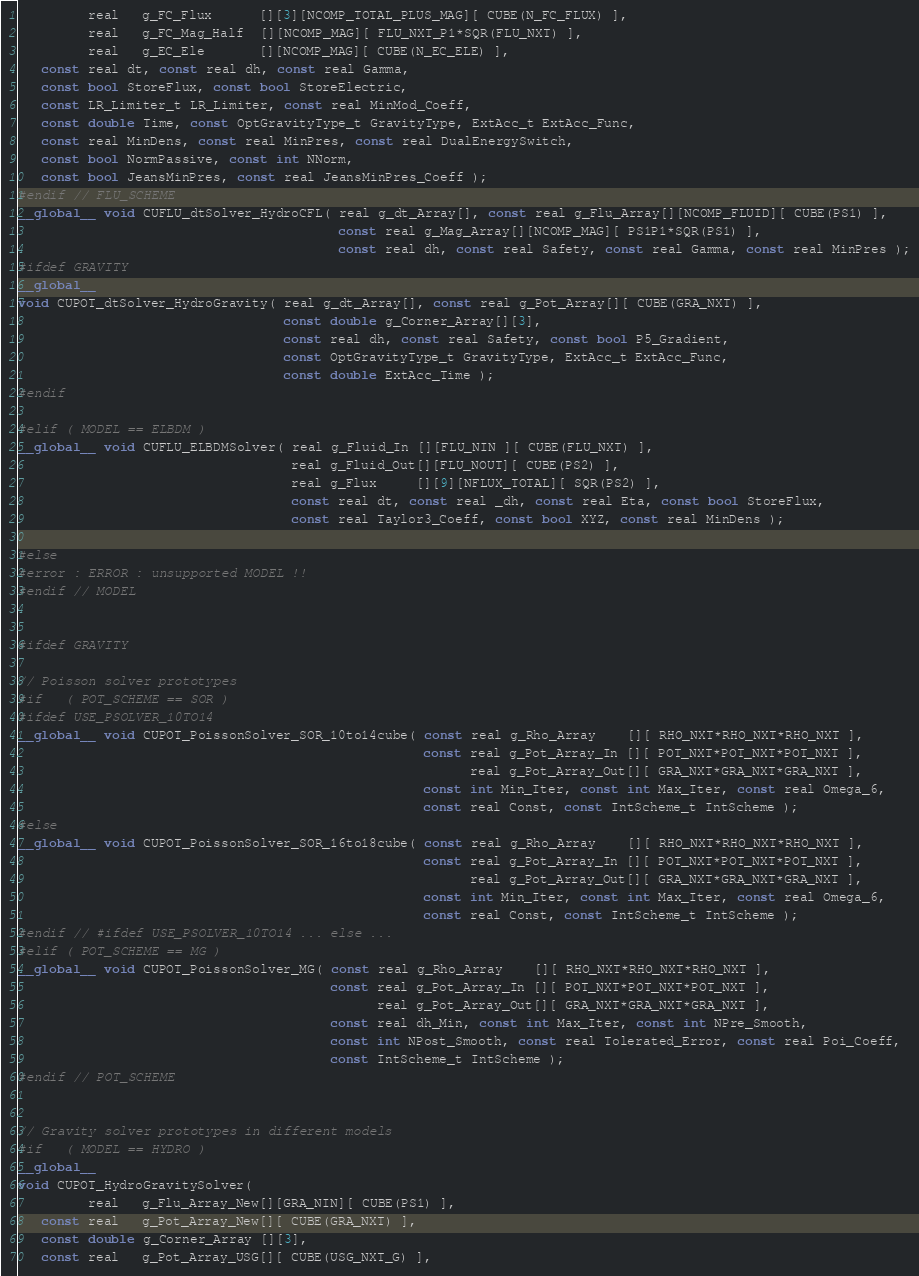<code> <loc_0><loc_0><loc_500><loc_500><_Cuda_>         real   g_FC_Flux      [][3][NCOMP_TOTAL_PLUS_MAG][ CUBE(N_FC_FLUX) ],
         real   g_FC_Mag_Half  [][NCOMP_MAG][ FLU_NXT_P1*SQR(FLU_NXT) ],
         real   g_EC_Ele       [][NCOMP_MAG][ CUBE(N_EC_ELE) ],
   const real dt, const real dh, const real Gamma,
   const bool StoreFlux, const bool StoreElectric,
   const LR_Limiter_t LR_Limiter, const real MinMod_Coeff,
   const double Time, const OptGravityType_t GravityType, ExtAcc_t ExtAcc_Func,
   const real MinDens, const real MinPres, const real DualEnergySwitch,
   const bool NormPassive, const int NNorm,
   const bool JeansMinPres, const real JeansMinPres_Coeff );
#endif // FLU_SCHEME
__global__ void CUFLU_dtSolver_HydroCFL( real g_dt_Array[], const real g_Flu_Array[][NCOMP_FLUID][ CUBE(PS1) ],
                                         const real g_Mag_Array[][NCOMP_MAG][ PS1P1*SQR(PS1) ],
                                         const real dh, const real Safety, const real Gamma, const real MinPres );
#ifdef GRAVITY
__global__
void CUPOT_dtSolver_HydroGravity( real g_dt_Array[], const real g_Pot_Array[][ CUBE(GRA_NXT) ],
                                  const double g_Corner_Array[][3],
                                  const real dh, const real Safety, const bool P5_Gradient,
                                  const OptGravityType_t GravityType, ExtAcc_t ExtAcc_Func,
                                  const double ExtAcc_Time );
#endif

#elif ( MODEL == ELBDM )
__global__ void CUFLU_ELBDMSolver( real g_Fluid_In [][FLU_NIN ][ CUBE(FLU_NXT) ],
                                   real g_Fluid_Out[][FLU_NOUT][ CUBE(PS2) ],
                                   real g_Flux     [][9][NFLUX_TOTAL][ SQR(PS2) ],
                                   const real dt, const real _dh, const real Eta, const bool StoreFlux,
                                   const real Taylor3_Coeff, const bool XYZ, const real MinDens );

#else
#error : ERROR : unsupported MODEL !!
#endif // MODEL


#ifdef GRAVITY

// Poisson solver prototypes
#if   ( POT_SCHEME == SOR )
#ifdef USE_PSOLVER_10TO14
__global__ void CUPOT_PoissonSolver_SOR_10to14cube( const real g_Rho_Array    [][ RHO_NXT*RHO_NXT*RHO_NXT ],
                                                    const real g_Pot_Array_In [][ POT_NXT*POT_NXT*POT_NXT ],
                                                          real g_Pot_Array_Out[][ GRA_NXT*GRA_NXT*GRA_NXT ],
                                                    const int Min_Iter, const int Max_Iter, const real Omega_6,
                                                    const real Const, const IntScheme_t IntScheme );
#else
__global__ void CUPOT_PoissonSolver_SOR_16to18cube( const real g_Rho_Array    [][ RHO_NXT*RHO_NXT*RHO_NXT ],
                                                    const real g_Pot_Array_In [][ POT_NXT*POT_NXT*POT_NXT ],
                                                          real g_Pot_Array_Out[][ GRA_NXT*GRA_NXT*GRA_NXT ],
                                                    const int Min_Iter, const int Max_Iter, const real Omega_6,
                                                    const real Const, const IntScheme_t IntScheme );
#endif // #ifdef USE_PSOLVER_10TO14 ... else ...
#elif ( POT_SCHEME == MG )
__global__ void CUPOT_PoissonSolver_MG( const real g_Rho_Array    [][ RHO_NXT*RHO_NXT*RHO_NXT ],
                                        const real g_Pot_Array_In [][ POT_NXT*POT_NXT*POT_NXT ],
                                              real g_Pot_Array_Out[][ GRA_NXT*GRA_NXT*GRA_NXT ],
                                        const real dh_Min, const int Max_Iter, const int NPre_Smooth,
                                        const int NPost_Smooth, const real Tolerated_Error, const real Poi_Coeff,
                                        const IntScheme_t IntScheme );
#endif // POT_SCHEME


// Gravity solver prototypes in different models
#if   ( MODEL == HYDRO )
__global__
void CUPOT_HydroGravitySolver(
         real   g_Flu_Array_New[][GRA_NIN][ CUBE(PS1) ],
   const real   g_Pot_Array_New[][ CUBE(GRA_NXT) ],
   const double g_Corner_Array [][3],
   const real   g_Pot_Array_USG[][ CUBE(USG_NXT_G) ],</code> 